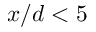<formula> <loc_0><loc_0><loc_500><loc_500>x / d < 5</formula> 